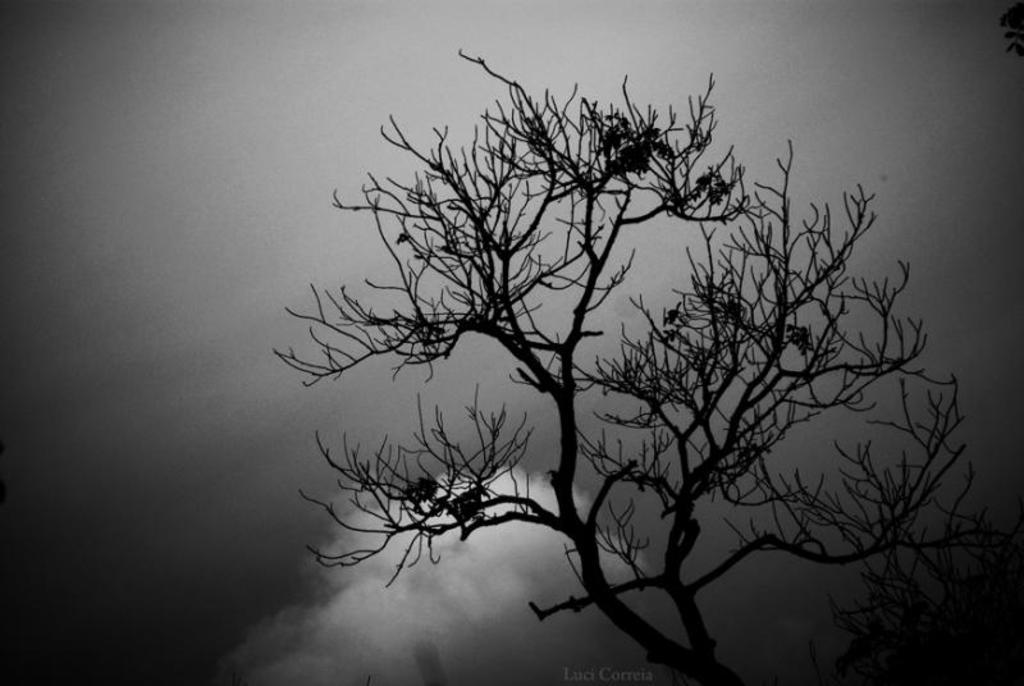What type of plant can be seen in the image? There is a tree in the image. What is the weather condition in the image? There is snow in the image, which suggests a cold or wintery environment. What color is the background of the image? The background of the image appears to be black. What type of liquid is being poured by the dad in the image? There is no dad or liquid being poured in the image; it only features a tree and snow with a black background. 